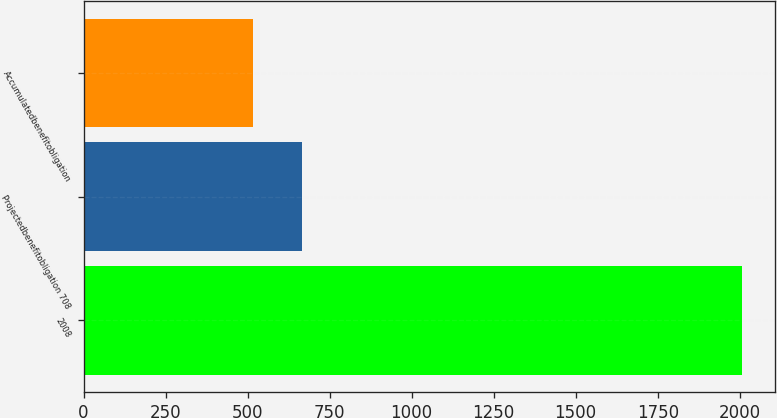Convert chart to OTSL. <chart><loc_0><loc_0><loc_500><loc_500><bar_chart><fcel>2008<fcel>Projectedbenefitobligation 708<fcel>Accumulatedbenefitobligation<nl><fcel>2007<fcel>666<fcel>517<nl></chart> 